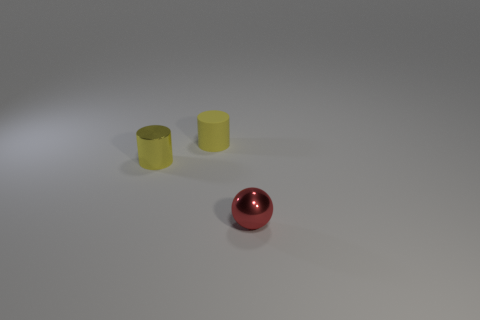How many things are either cyan blocks or metallic objects that are behind the red shiny ball?
Give a very brief answer. 1. The small cylinder that is made of the same material as the small red sphere is what color?
Ensure brevity in your answer.  Yellow. How many things are either small cyan cylinders or small yellow metal things?
Keep it short and to the point. 1. What is the color of the matte thing that is the same size as the red ball?
Offer a very short reply. Yellow. How many objects are metal objects to the left of the red shiny ball or tiny blue balls?
Provide a short and direct response. 1. How many other things are there of the same size as the rubber cylinder?
Keep it short and to the point. 2. What size is the shiny thing that is on the left side of the sphere?
Offer a terse response. Small. There is a tiny yellow object that is made of the same material as the small red thing; what shape is it?
Make the answer very short. Cylinder. Is there anything else that is the same color as the tiny metal ball?
Keep it short and to the point. No. What color is the cylinder behind the metal thing behind the red shiny sphere?
Provide a succinct answer. Yellow. 